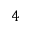Convert formula to latex. <formula><loc_0><loc_0><loc_500><loc_500>4</formula> 